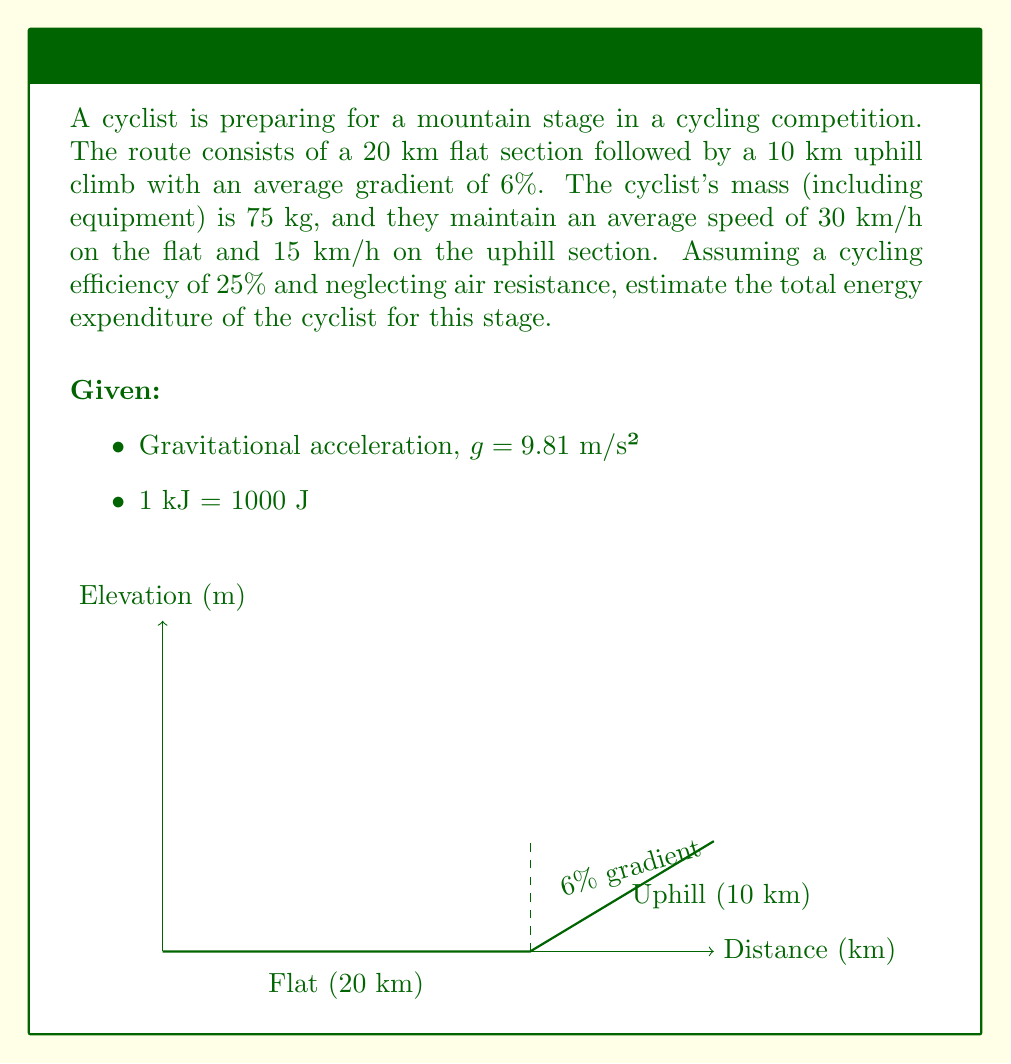Could you help me with this problem? To estimate the total energy expenditure, we need to calculate the work done on both the flat and uphill sections, then account for the cyclist's efficiency.

Step 1: Calculate work done on the flat section
On the flat section, we only consider the work against rolling resistance.
Rolling resistance coefficient for a typical road bike ≈ 0.005
Work on flat = Force × Distance = (Mass × g × Rolling resistance coefficient) × Distance
$$W_{flat} = 75 \times 9.81 \times 0.005 \times 20000 = 7357.5 \text{ J}$$

Step 2: Calculate work done on the uphill section
For the uphill section, we need to calculate both the work against gravity and rolling resistance.
Elevation gain = 10000 m × 6% = 600 m
Work against gravity = Mass × g × Elevation gain
$$W_{gravity} = 75 \times 9.81 \times 600 = 441450 \text{ J}$$
Work against rolling resistance (uphill) = 75 × 9.81 × 0.005 × 10000 = 3678.75 J
Total work uphill = 441450 + 3678.75 = 445128.75 J

Step 3: Calculate total work done
Total work = Work on flat + Work uphill
$$W_{total} = 7357.5 + 445128.75 = 452486.25 \text{ J}$$

Step 4: Account for cycling efficiency
Given efficiency is 25%, so the total energy expenditure is:
$$E_{total} = \frac{W_{total}}{0.25} = \frac{452486.25}{0.25} = 1809945 \text{ J}$$

Step 5: Convert to kJ
$$E_{total} = 1809945 \text{ J} = 1809.945 \text{ kJ}$$

Therefore, the estimated total energy expenditure is approximately 1810 kJ.
Answer: 1810 kJ 